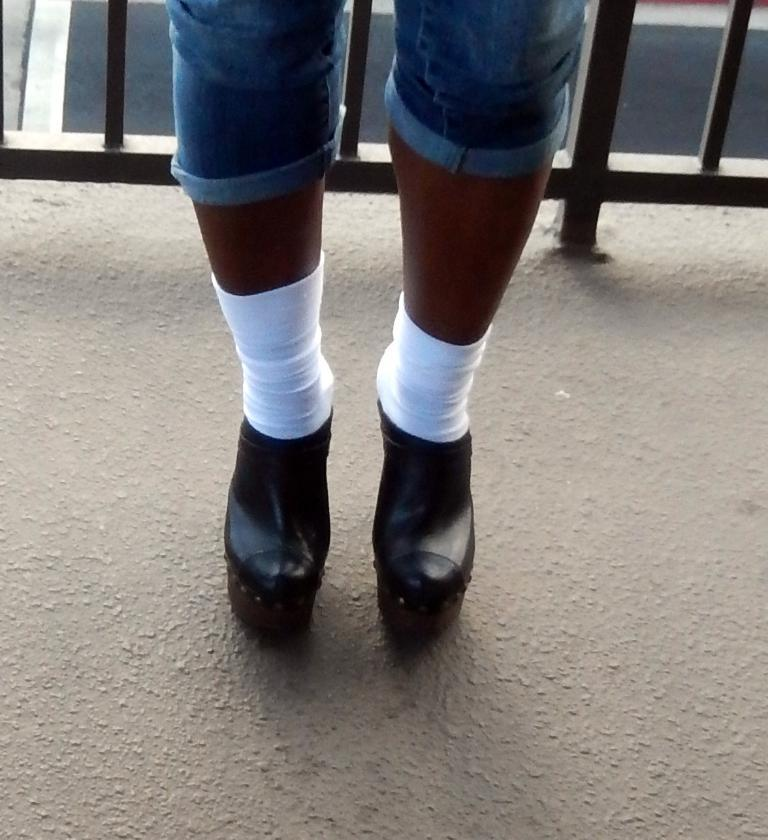What is visible in the image related to a person's leg? There is a person's leg with shoes in the image. How are the shoes positioned in relation to the ground? The shoes are placed on the ground. What can be seen in the background of the image? There is a metal railing in the background of the image. What type of pickle is being held by the person in the image? There is no person or pickle visible in the image; it only shows a person's leg with shoes. What sign can be seen near the metal railing in the image? There is no sign visible near the metal railing in the image. 